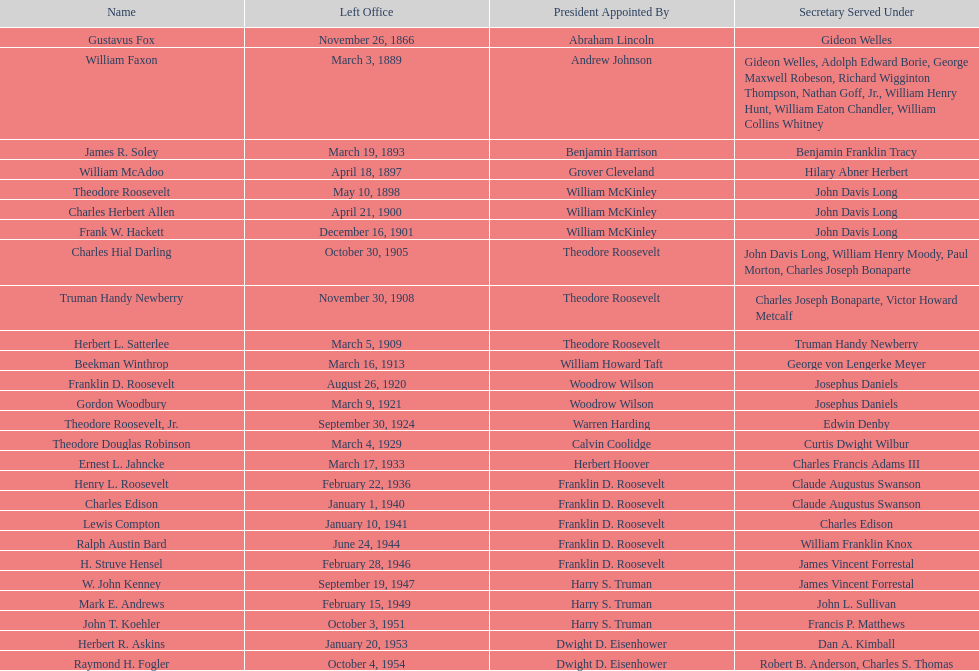Who was the first assistant secretary of the navy? Gustavus Fox. 